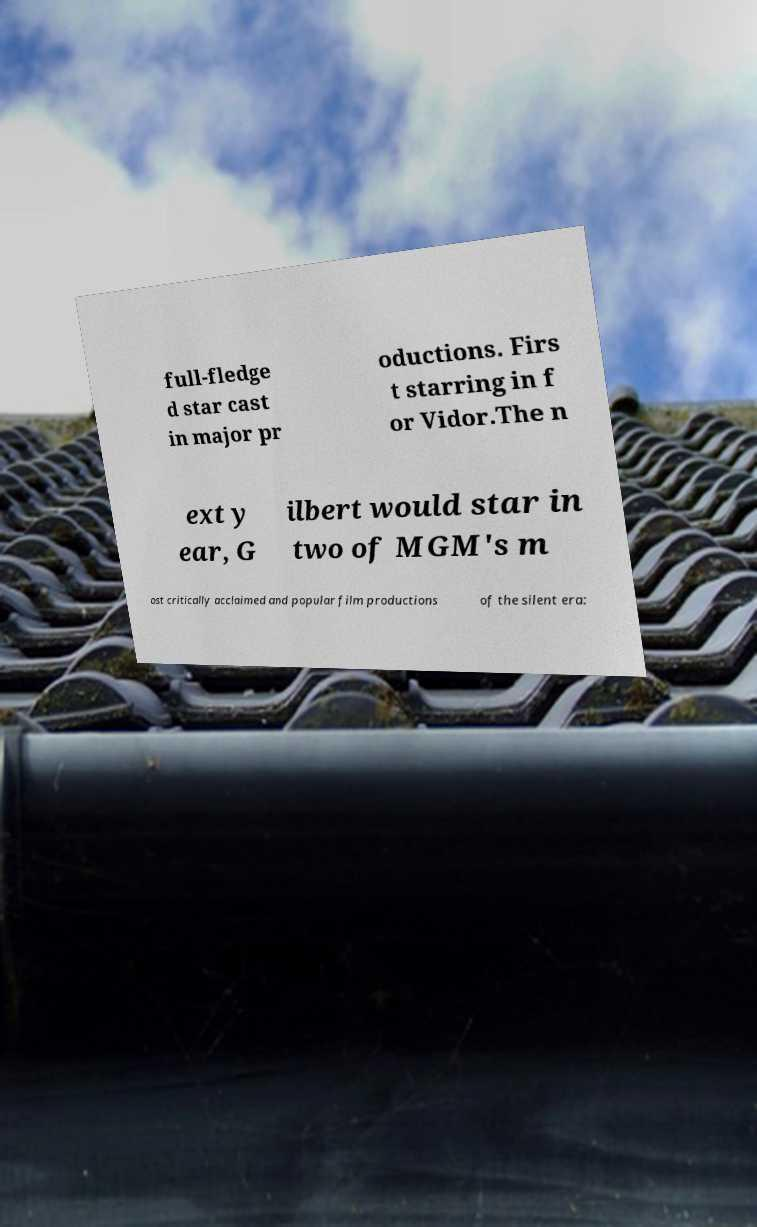Please identify and transcribe the text found in this image. full-fledge d star cast in major pr oductions. Firs t starring in f or Vidor.The n ext y ear, G ilbert would star in two of MGM's m ost critically acclaimed and popular film productions of the silent era: 